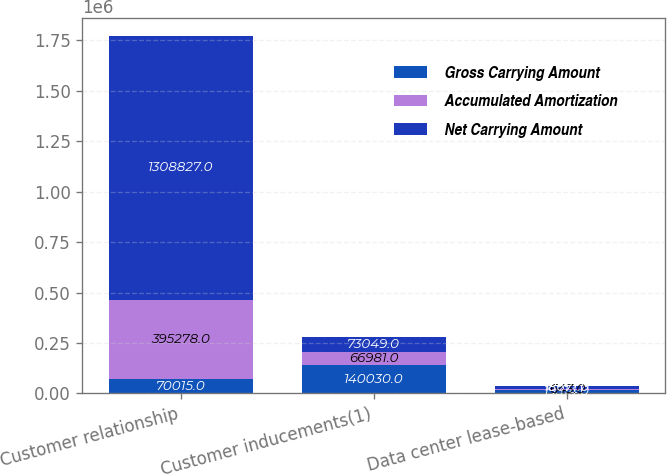Convert chart. <chart><loc_0><loc_0><loc_500><loc_500><stacked_bar_chart><ecel><fcel>Customer relationship<fcel>Customer inducements(1)<fcel>Data center lease-based<nl><fcel>Gross Carrying Amount<fcel>70015<fcel>140030<fcel>19314<nl><fcel>Accumulated Amortization<fcel>395278<fcel>66981<fcel>643<nl><fcel>Net Carrying Amount<fcel>1.30883e+06<fcel>73049<fcel>18671<nl></chart> 